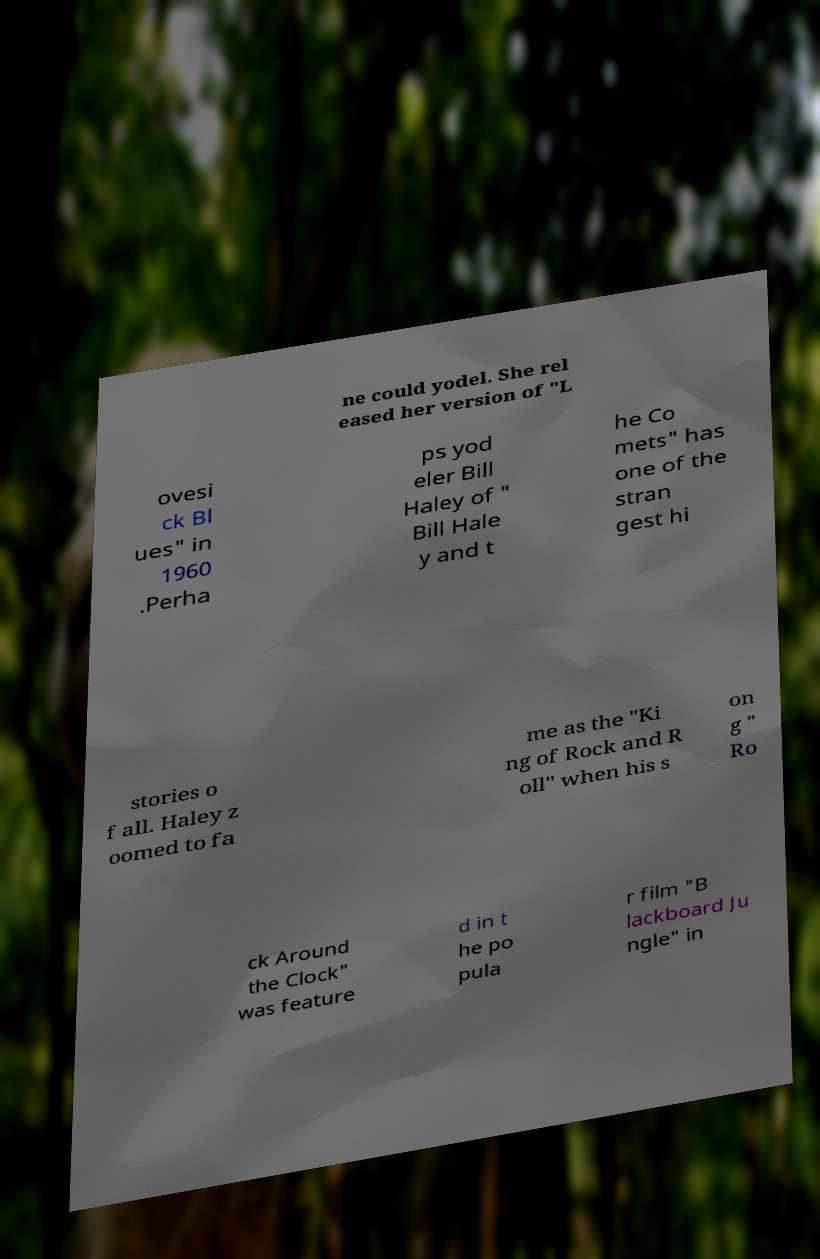I need the written content from this picture converted into text. Can you do that? ne could yodel. She rel eased her version of "L ovesi ck Bl ues" in 1960 .Perha ps yod eler Bill Haley of " Bill Hale y and t he Co mets" has one of the stran gest hi stories o f all. Haley z oomed to fa me as the "Ki ng of Rock and R oll" when his s on g " Ro ck Around the Clock" was feature d in t he po pula r film "B lackboard Ju ngle" in 